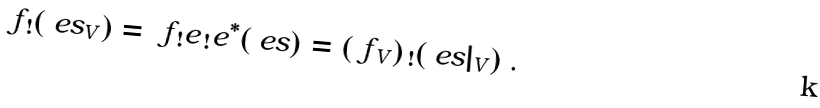<formula> <loc_0><loc_0><loc_500><loc_500>\ f _ { \, ! } ( \ e s _ { V } ) = \ f _ { \, ! } e _ { \, ! } e ^ { * } ( \ e s ) = ( \ f _ { \, V } ) _ { \, ! } ( \ e s | _ { V } ) \ .</formula> 